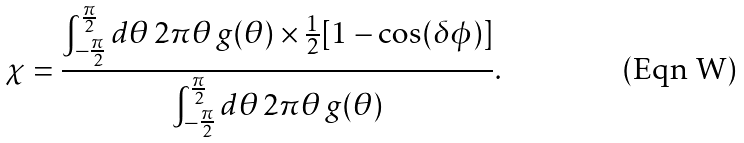<formula> <loc_0><loc_0><loc_500><loc_500>\chi = \frac { \int _ { - \frac { \pi } { 2 } } ^ { \frac { \pi } { 2 } } d \theta \, 2 \pi \theta \, g ( \theta ) \times \frac { 1 } { 2 } [ 1 - \cos ( \delta \phi ) ] } { \int _ { - \frac { \pi } { 2 } } ^ { \frac { \pi } { 2 } } d \theta \, 2 \pi \theta \, g ( \theta ) } .</formula> 